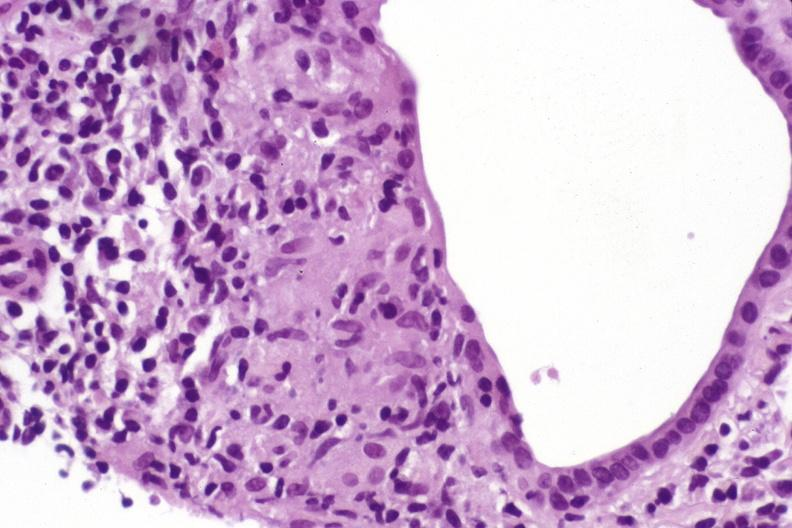s hepatobiliary present?
Answer the question using a single word or phrase. Yes 